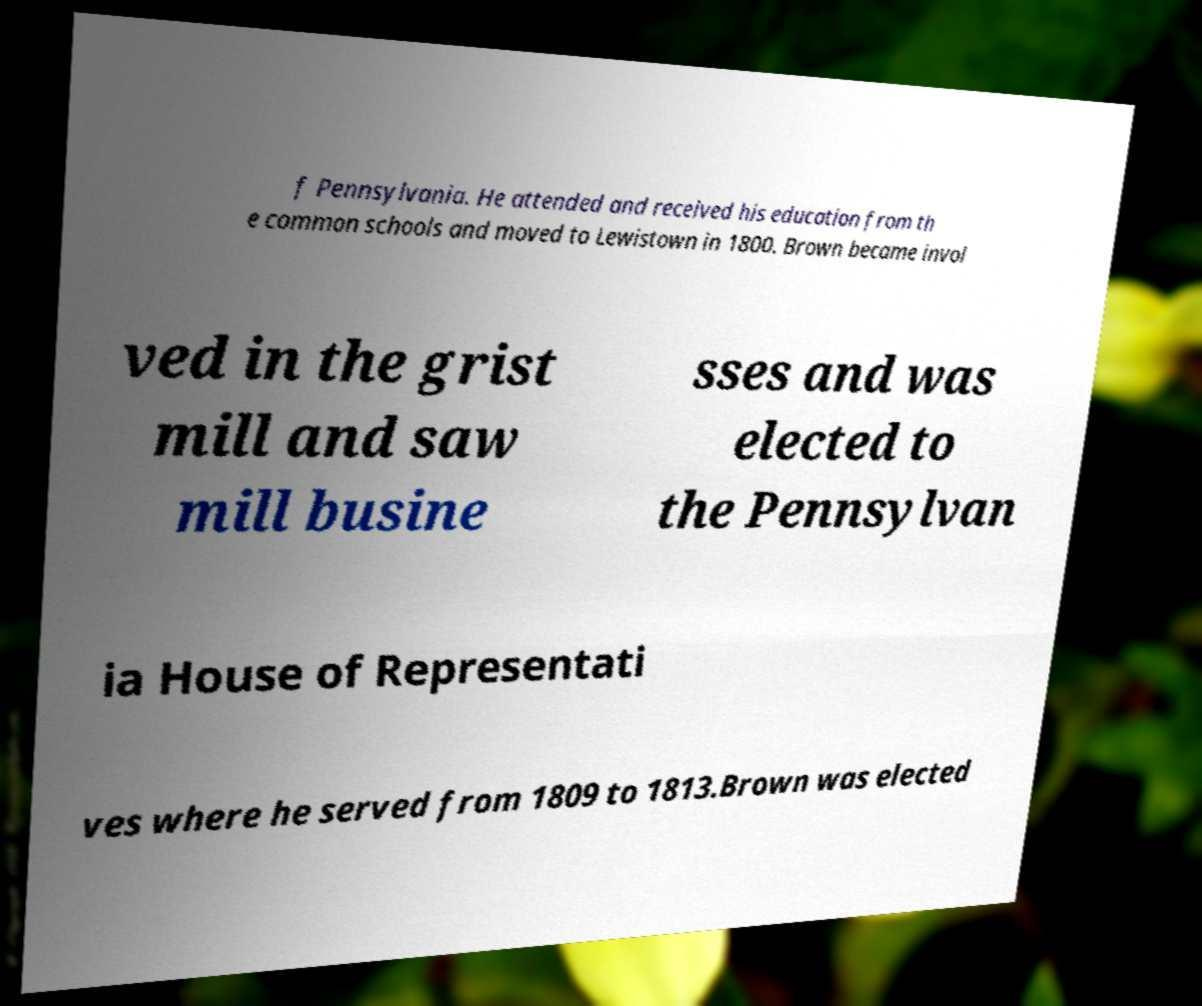I need the written content from this picture converted into text. Can you do that? f Pennsylvania. He attended and received his education from th e common schools and moved to Lewistown in 1800. Brown became invol ved in the grist mill and saw mill busine sses and was elected to the Pennsylvan ia House of Representati ves where he served from 1809 to 1813.Brown was elected 